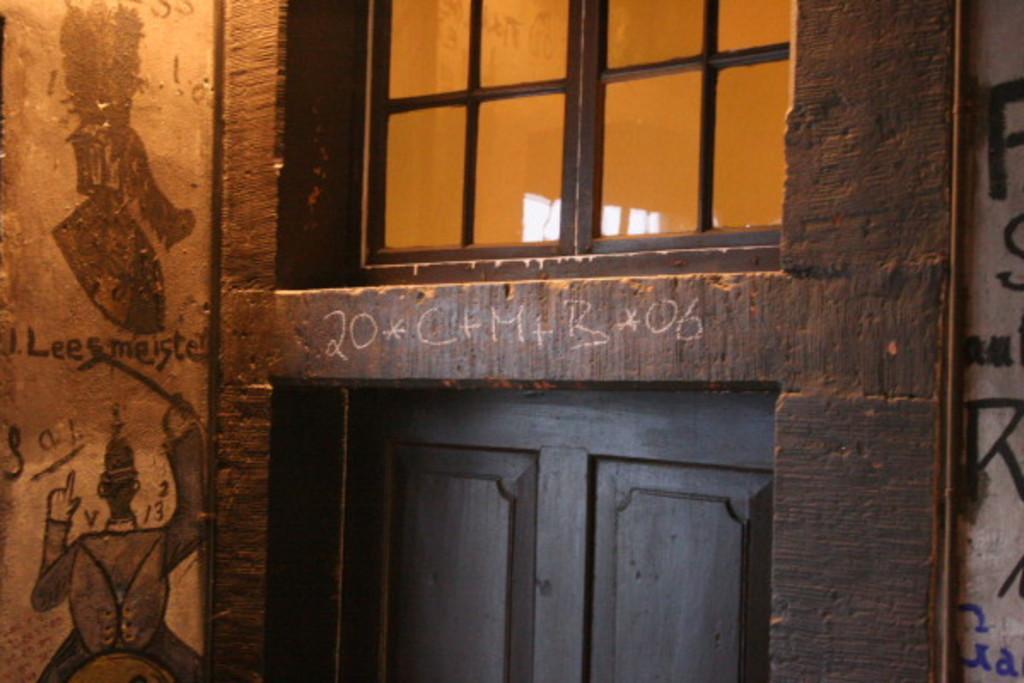How would you summarize this image in a sentence or two? In the image there is a window and under the window there is a door, on the left side there are some paintings on the wall. 